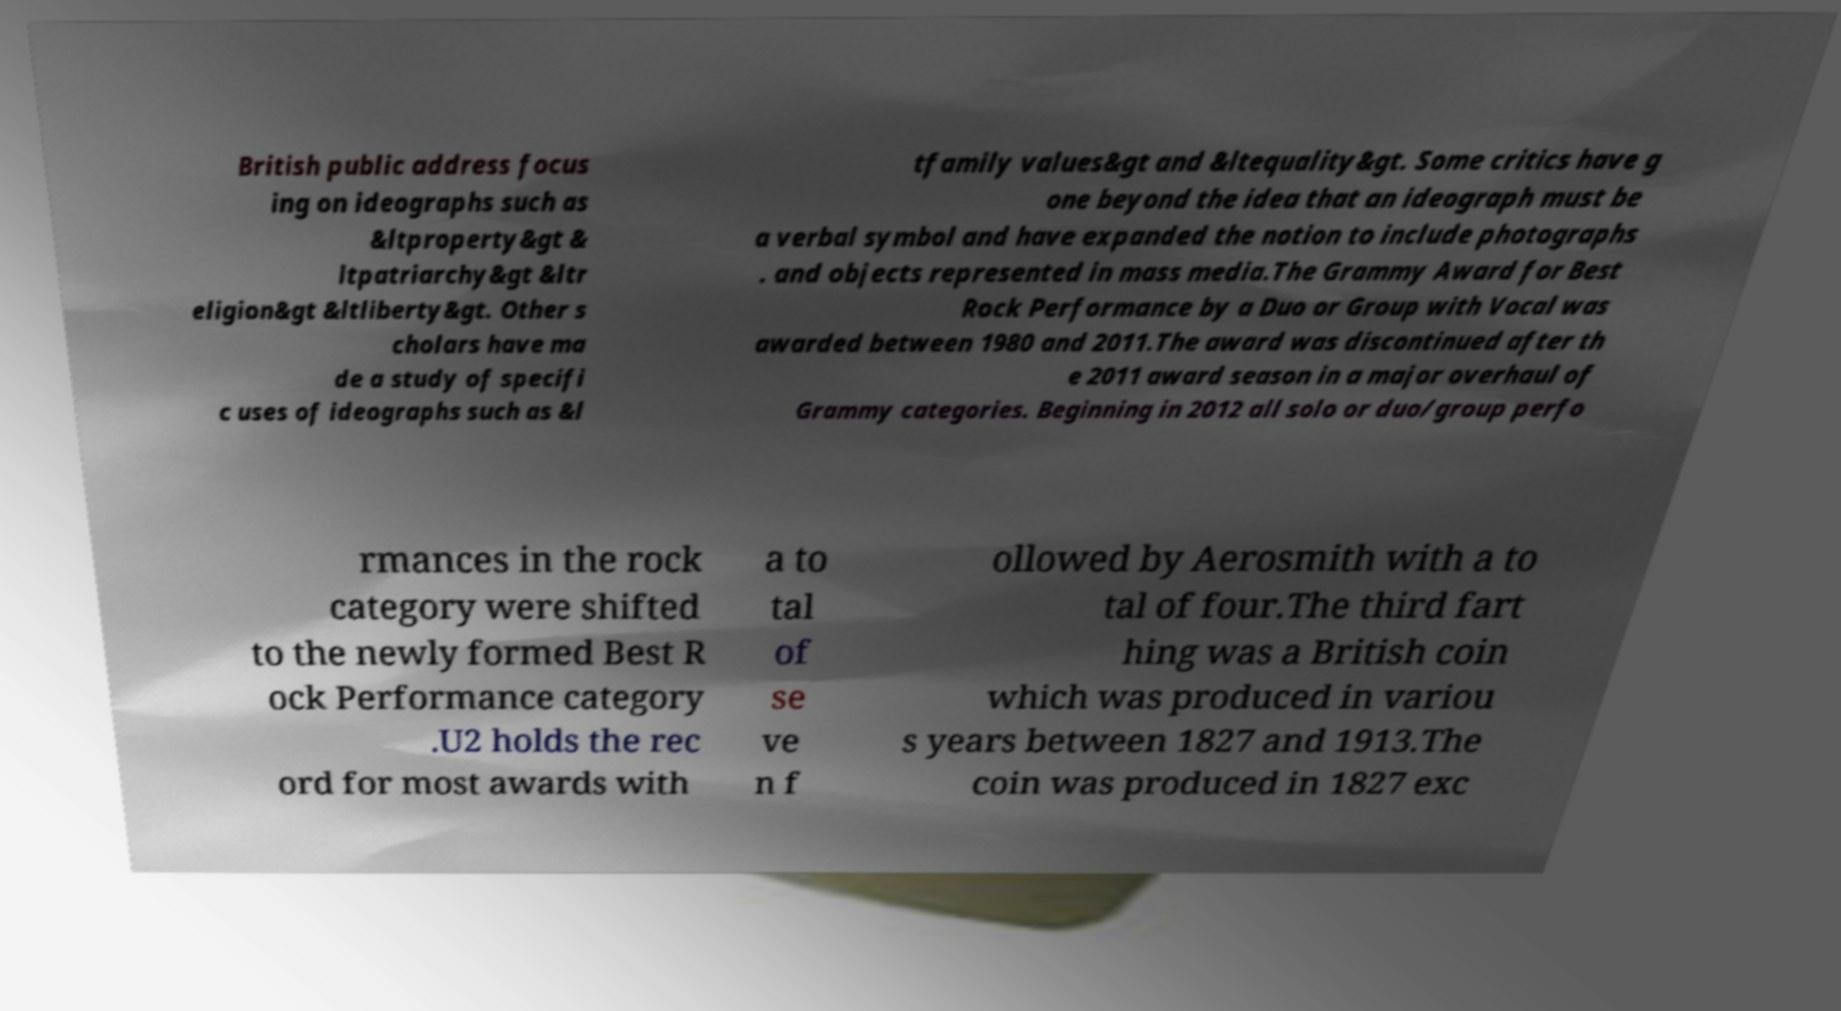For documentation purposes, I need the text within this image transcribed. Could you provide that? British public address focus ing on ideographs such as &ltproperty&gt & ltpatriarchy&gt &ltr eligion&gt &ltliberty&gt. Other s cholars have ma de a study of specifi c uses of ideographs such as &l tfamily values&gt and &ltequality&gt. Some critics have g one beyond the idea that an ideograph must be a verbal symbol and have expanded the notion to include photographs . and objects represented in mass media.The Grammy Award for Best Rock Performance by a Duo or Group with Vocal was awarded between 1980 and 2011.The award was discontinued after th e 2011 award season in a major overhaul of Grammy categories. Beginning in 2012 all solo or duo/group perfo rmances in the rock category were shifted to the newly formed Best R ock Performance category .U2 holds the rec ord for most awards with a to tal of se ve n f ollowed by Aerosmith with a to tal of four.The third fart hing was a British coin which was produced in variou s years between 1827 and 1913.The coin was produced in 1827 exc 